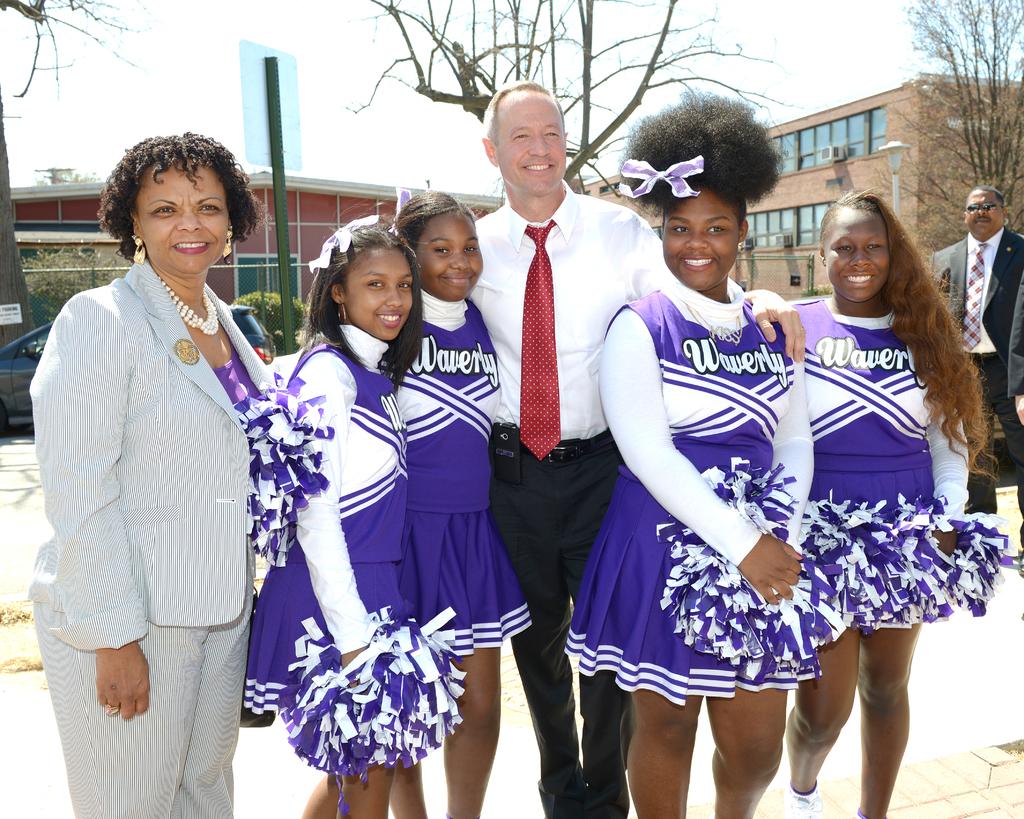What school do these girls cheer for?
Keep it short and to the point. Waverly. 